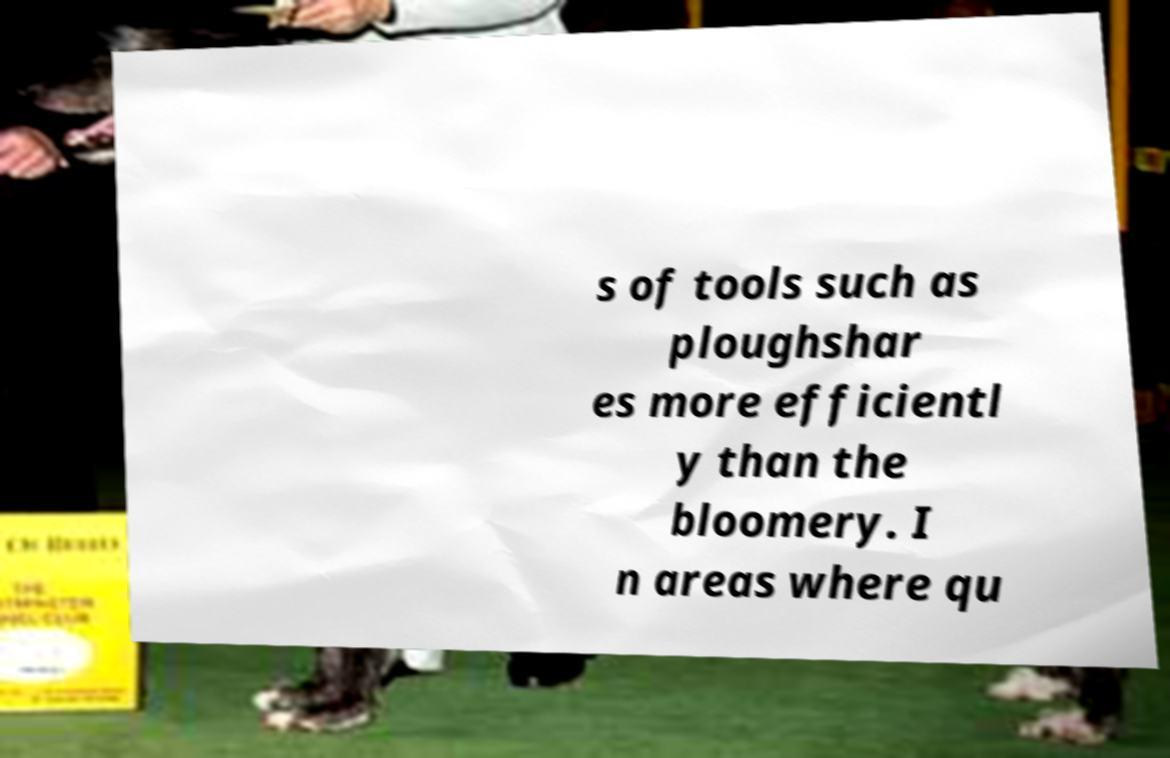Please identify and transcribe the text found in this image. s of tools such as ploughshar es more efficientl y than the bloomery. I n areas where qu 